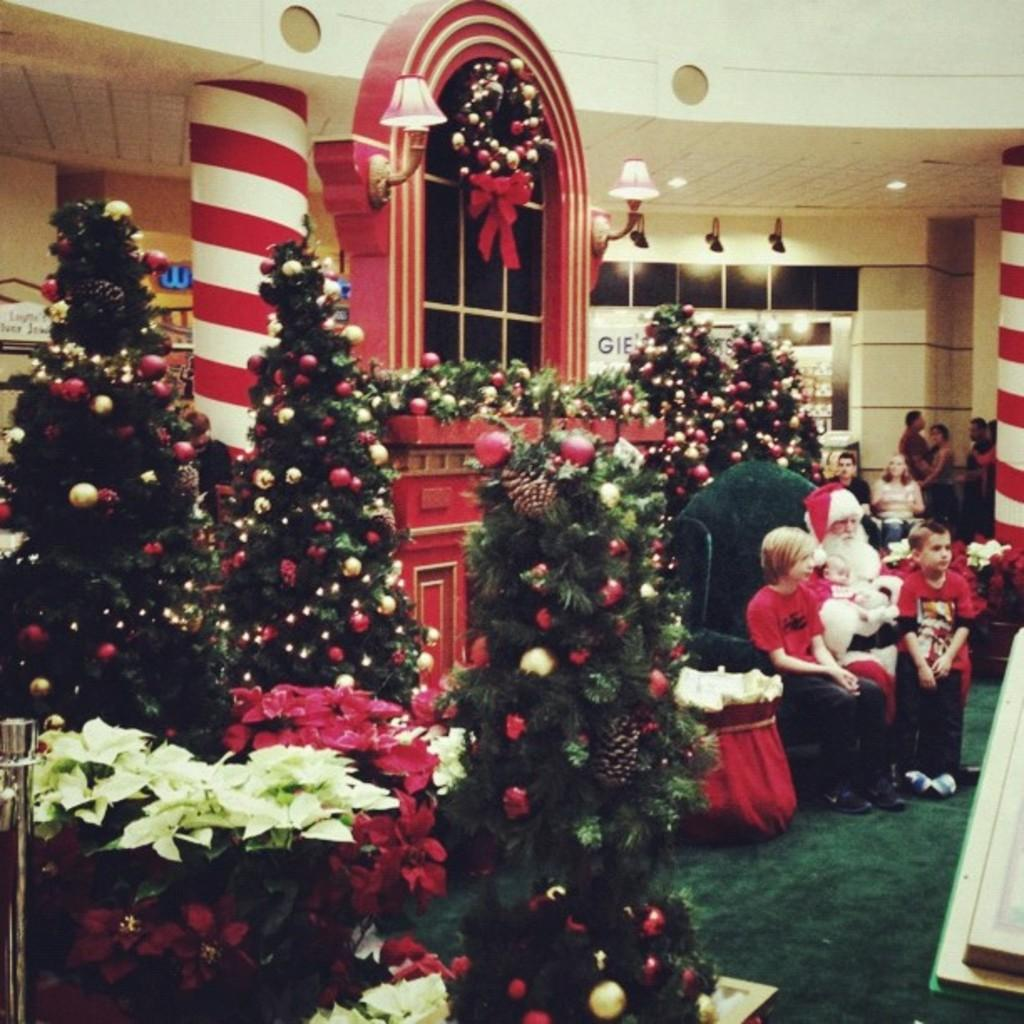What type of decorations are present in the image? There are decorated Christmas trees in the image. What other objects can be seen in the image? There are flower vases in the image. What are the people in the image doing? There are people sitting on chairs and standing on the floor in the image. What type of lighting is visible in the image? Electric lights are visible in the image. What type of structure is present in the image? There are walls in the image. What language is being spoken by the people in the image? The provided facts do not mention any spoken language, so it cannot be determined from the image. Is there any destruction or damage visible in the image? There is no mention of destruction or damage in the provided facts, and the image does not show any signs of it. 